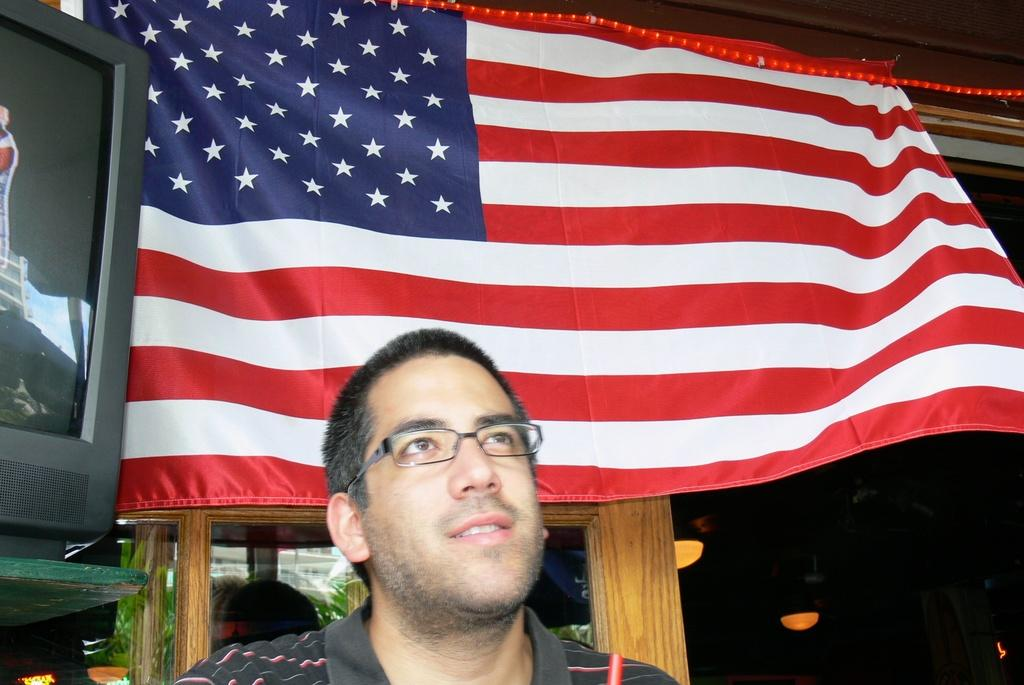Who is present in the image? There is a man in the image. What is located behind the man? There is a flag behind the man. What electronic device is visible in the image? There is a television in the image. What type of lighting is present in the image? There are ceiling lights visible in the image. What type of committee is meeting in the image? There is no committee present in the image; it only features a man, a flag, a television, and ceiling lights. What kind of hat is the man wearing in the image? The man is not wearing a hat in the image. 